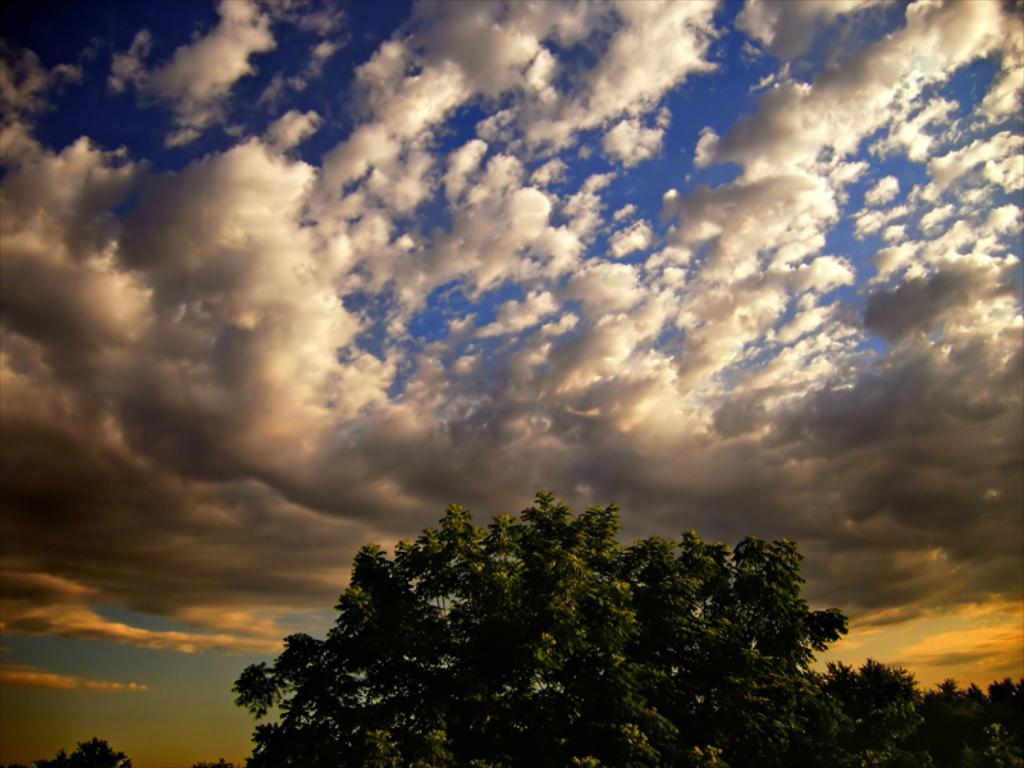What type of vegetation can be seen in the image? There are trees in the image. What part of the natural environment is visible in the image? The sky is visible in the image. Can you describe the sky in the image? The sky has heavy clouds in the image. What type of rifle can be seen in the image? There is no rifle present in the image. What show is being performed in the image? There is no show being performed in the image. 